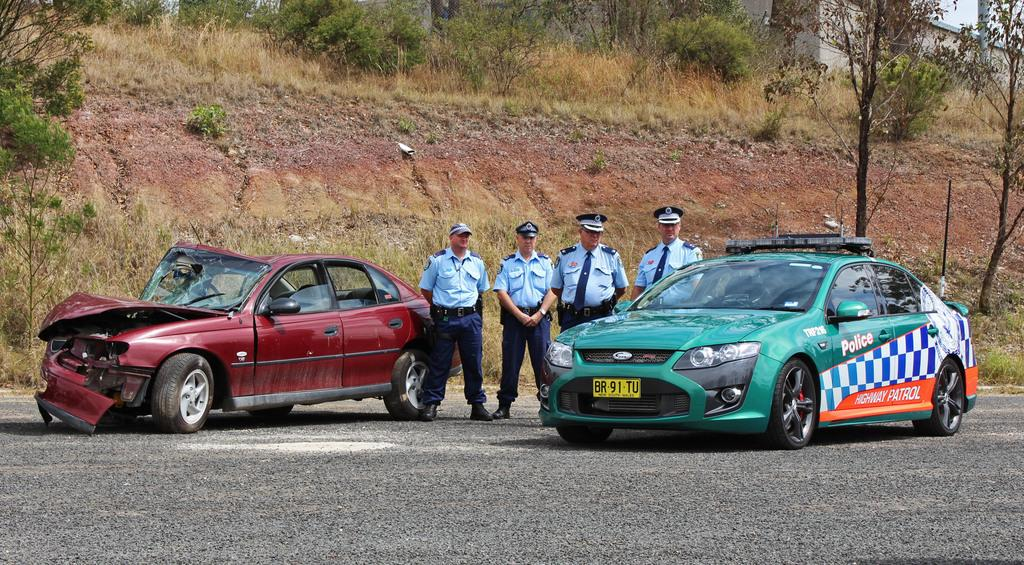How many police officers are present in the image? There are four police officers in the image. What type of vehicle is associated with the police officers in the image? There is a police car in the image. What event has occurred involving a car in the image? There is a car that has been involved in an accident in the image. Where is the accident scene located in the image? The accident scene is to the left corner of the image. What natural elements can be seen in the background of the image? There are: There are trees and bushes in the background of the image. Can you tell me how many mountains are visible in the image? There are no mountains visible in the image; only trees and bushes can be seen in the background. Is there a river flowing through the scene in the image? There is no river present in the image. 